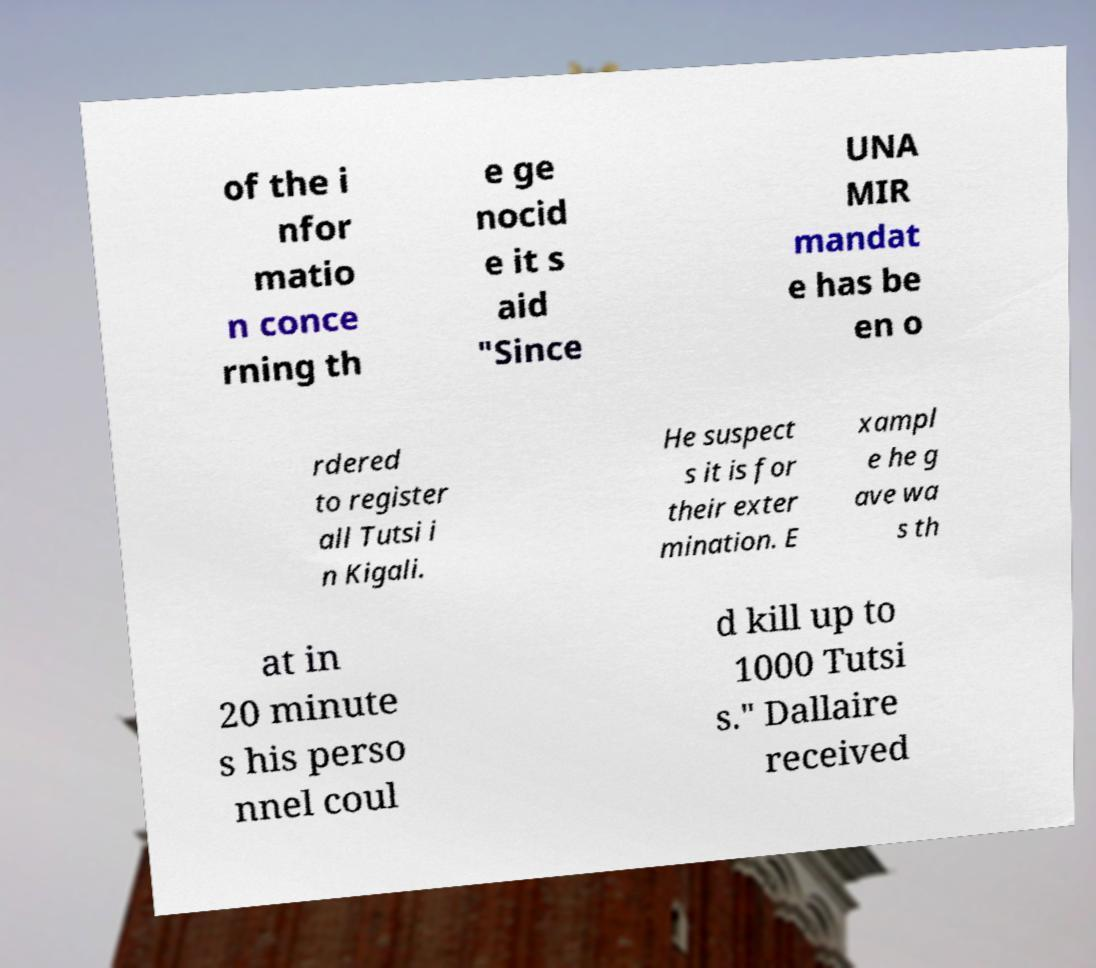Please identify and transcribe the text found in this image. of the i nfor matio n conce rning th e ge nocid e it s aid "Since UNA MIR mandat e has be en o rdered to register all Tutsi i n Kigali. He suspect s it is for their exter mination. E xampl e he g ave wa s th at in 20 minute s his perso nnel coul d kill up to 1000 Tutsi s." Dallaire received 